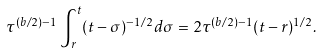Convert formula to latex. <formula><loc_0><loc_0><loc_500><loc_500>\tau ^ { ( b / 2 ) - 1 } \int _ { r } ^ { t } ( t - \sigma ) ^ { - 1 / 2 } d \sigma = 2 \tau ^ { ( b / 2 ) - 1 } ( t - r ) ^ { 1 / 2 } .</formula> 